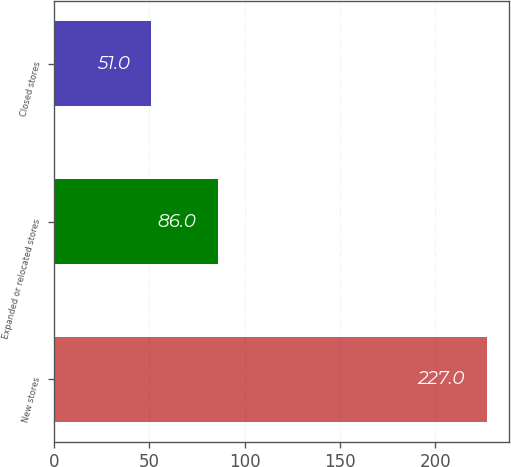<chart> <loc_0><loc_0><loc_500><loc_500><bar_chart><fcel>New stores<fcel>Expanded or relocated stores<fcel>Closed stores<nl><fcel>227<fcel>86<fcel>51<nl></chart> 